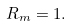Convert formula to latex. <formula><loc_0><loc_0><loc_500><loc_500>R _ { m } = 1 .</formula> 